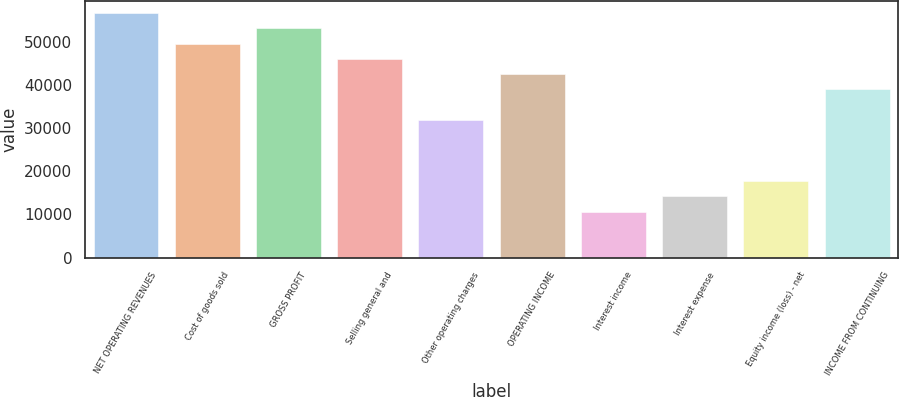<chart> <loc_0><loc_0><loc_500><loc_500><bar_chart><fcel>NET OPERATING REVENUES<fcel>Cost of goods sold<fcel>GROSS PROFIT<fcel>Selling general and<fcel>Other operating charges<fcel>OPERATING INCOME<fcel>Interest income<fcel>Interest expense<fcel>Equity income (loss) - net<fcel>INCOME FROM CONTINUING<nl><fcel>56655.8<fcel>49573.9<fcel>53114.8<fcel>46032.9<fcel>31869<fcel>42491.9<fcel>10623.2<fcel>14164.2<fcel>17705.1<fcel>38951<nl></chart> 